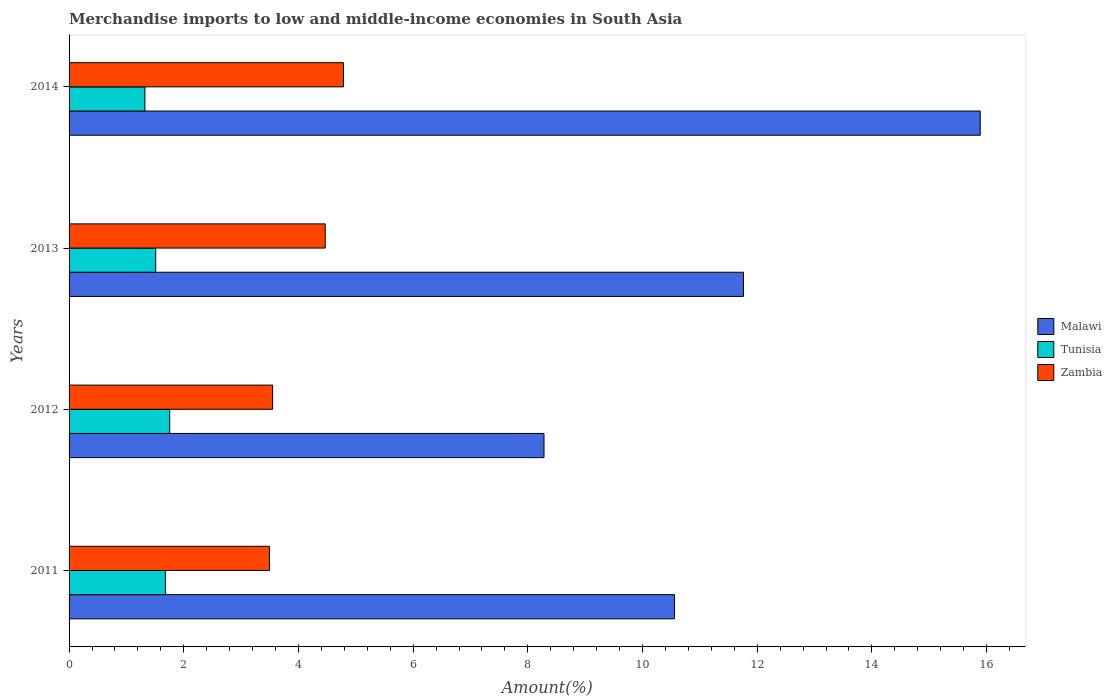Are the number of bars on each tick of the Y-axis equal?
Offer a terse response. Yes. How many bars are there on the 2nd tick from the top?
Provide a succinct answer. 3. What is the label of the 2nd group of bars from the top?
Your answer should be very brief. 2013. In how many cases, is the number of bars for a given year not equal to the number of legend labels?
Offer a very short reply. 0. What is the percentage of amount earned from merchandise imports in Tunisia in 2014?
Your answer should be very brief. 1.32. Across all years, what is the maximum percentage of amount earned from merchandise imports in Tunisia?
Give a very brief answer. 1.75. Across all years, what is the minimum percentage of amount earned from merchandise imports in Malawi?
Keep it short and to the point. 8.28. What is the total percentage of amount earned from merchandise imports in Zambia in the graph?
Your answer should be compact. 16.3. What is the difference between the percentage of amount earned from merchandise imports in Tunisia in 2011 and that in 2014?
Your response must be concise. 0.36. What is the difference between the percentage of amount earned from merchandise imports in Malawi in 2014 and the percentage of amount earned from merchandise imports in Zambia in 2012?
Your response must be concise. 12.34. What is the average percentage of amount earned from merchandise imports in Tunisia per year?
Offer a terse response. 1.57. In the year 2011, what is the difference between the percentage of amount earned from merchandise imports in Tunisia and percentage of amount earned from merchandise imports in Malawi?
Your answer should be compact. -8.88. What is the ratio of the percentage of amount earned from merchandise imports in Malawi in 2011 to that in 2012?
Give a very brief answer. 1.27. Is the percentage of amount earned from merchandise imports in Tunisia in 2012 less than that in 2014?
Offer a terse response. No. What is the difference between the highest and the second highest percentage of amount earned from merchandise imports in Tunisia?
Offer a very short reply. 0.07. What is the difference between the highest and the lowest percentage of amount earned from merchandise imports in Malawi?
Make the answer very short. 7.61. Is the sum of the percentage of amount earned from merchandise imports in Tunisia in 2011 and 2012 greater than the maximum percentage of amount earned from merchandise imports in Malawi across all years?
Give a very brief answer. No. What does the 3rd bar from the top in 2014 represents?
Your response must be concise. Malawi. What does the 3rd bar from the bottom in 2013 represents?
Offer a terse response. Zambia. Are all the bars in the graph horizontal?
Give a very brief answer. Yes. How many years are there in the graph?
Ensure brevity in your answer.  4. Are the values on the major ticks of X-axis written in scientific E-notation?
Your answer should be very brief. No. How many legend labels are there?
Your answer should be compact. 3. How are the legend labels stacked?
Your response must be concise. Vertical. What is the title of the graph?
Provide a short and direct response. Merchandise imports to low and middle-income economies in South Asia. Does "Korea (Republic)" appear as one of the legend labels in the graph?
Make the answer very short. No. What is the label or title of the X-axis?
Your answer should be very brief. Amount(%). What is the label or title of the Y-axis?
Your response must be concise. Years. What is the Amount(%) of Malawi in 2011?
Make the answer very short. 10.56. What is the Amount(%) of Tunisia in 2011?
Offer a very short reply. 1.68. What is the Amount(%) of Zambia in 2011?
Offer a very short reply. 3.49. What is the Amount(%) in Malawi in 2012?
Make the answer very short. 8.28. What is the Amount(%) in Tunisia in 2012?
Keep it short and to the point. 1.75. What is the Amount(%) in Zambia in 2012?
Give a very brief answer. 3.55. What is the Amount(%) of Malawi in 2013?
Ensure brevity in your answer.  11.76. What is the Amount(%) in Tunisia in 2013?
Offer a terse response. 1.51. What is the Amount(%) of Zambia in 2013?
Make the answer very short. 4.47. What is the Amount(%) of Malawi in 2014?
Provide a short and direct response. 15.89. What is the Amount(%) of Tunisia in 2014?
Your response must be concise. 1.32. What is the Amount(%) of Zambia in 2014?
Your answer should be very brief. 4.79. Across all years, what is the maximum Amount(%) of Malawi?
Make the answer very short. 15.89. Across all years, what is the maximum Amount(%) of Tunisia?
Ensure brevity in your answer.  1.75. Across all years, what is the maximum Amount(%) in Zambia?
Make the answer very short. 4.79. Across all years, what is the minimum Amount(%) in Malawi?
Ensure brevity in your answer.  8.28. Across all years, what is the minimum Amount(%) of Tunisia?
Provide a short and direct response. 1.32. Across all years, what is the minimum Amount(%) of Zambia?
Keep it short and to the point. 3.49. What is the total Amount(%) in Malawi in the graph?
Give a very brief answer. 46.49. What is the total Amount(%) of Tunisia in the graph?
Offer a terse response. 6.27. What is the total Amount(%) in Zambia in the graph?
Offer a very short reply. 16.3. What is the difference between the Amount(%) of Malawi in 2011 and that in 2012?
Your answer should be very brief. 2.28. What is the difference between the Amount(%) in Tunisia in 2011 and that in 2012?
Provide a short and direct response. -0.07. What is the difference between the Amount(%) in Zambia in 2011 and that in 2012?
Provide a succinct answer. -0.06. What is the difference between the Amount(%) in Malawi in 2011 and that in 2013?
Your response must be concise. -1.2. What is the difference between the Amount(%) of Tunisia in 2011 and that in 2013?
Your answer should be compact. 0.17. What is the difference between the Amount(%) of Zambia in 2011 and that in 2013?
Your response must be concise. -0.97. What is the difference between the Amount(%) of Malawi in 2011 and that in 2014?
Your answer should be compact. -5.33. What is the difference between the Amount(%) of Tunisia in 2011 and that in 2014?
Your answer should be compact. 0.36. What is the difference between the Amount(%) of Zambia in 2011 and that in 2014?
Offer a terse response. -1.29. What is the difference between the Amount(%) in Malawi in 2012 and that in 2013?
Make the answer very short. -3.48. What is the difference between the Amount(%) of Tunisia in 2012 and that in 2013?
Your answer should be compact. 0.24. What is the difference between the Amount(%) of Zambia in 2012 and that in 2013?
Your answer should be compact. -0.92. What is the difference between the Amount(%) in Malawi in 2012 and that in 2014?
Keep it short and to the point. -7.61. What is the difference between the Amount(%) in Tunisia in 2012 and that in 2014?
Make the answer very short. 0.43. What is the difference between the Amount(%) in Zambia in 2012 and that in 2014?
Offer a very short reply. -1.24. What is the difference between the Amount(%) in Malawi in 2013 and that in 2014?
Your answer should be very brief. -4.13. What is the difference between the Amount(%) of Tunisia in 2013 and that in 2014?
Give a very brief answer. 0.19. What is the difference between the Amount(%) of Zambia in 2013 and that in 2014?
Provide a short and direct response. -0.32. What is the difference between the Amount(%) in Malawi in 2011 and the Amount(%) in Tunisia in 2012?
Offer a very short reply. 8.8. What is the difference between the Amount(%) of Malawi in 2011 and the Amount(%) of Zambia in 2012?
Your response must be concise. 7.01. What is the difference between the Amount(%) in Tunisia in 2011 and the Amount(%) in Zambia in 2012?
Provide a succinct answer. -1.87. What is the difference between the Amount(%) in Malawi in 2011 and the Amount(%) in Tunisia in 2013?
Your answer should be compact. 9.05. What is the difference between the Amount(%) in Malawi in 2011 and the Amount(%) in Zambia in 2013?
Give a very brief answer. 6.09. What is the difference between the Amount(%) in Tunisia in 2011 and the Amount(%) in Zambia in 2013?
Provide a short and direct response. -2.79. What is the difference between the Amount(%) in Malawi in 2011 and the Amount(%) in Tunisia in 2014?
Offer a very short reply. 9.24. What is the difference between the Amount(%) in Malawi in 2011 and the Amount(%) in Zambia in 2014?
Your answer should be compact. 5.77. What is the difference between the Amount(%) of Tunisia in 2011 and the Amount(%) of Zambia in 2014?
Keep it short and to the point. -3.11. What is the difference between the Amount(%) of Malawi in 2012 and the Amount(%) of Tunisia in 2013?
Your answer should be compact. 6.77. What is the difference between the Amount(%) in Malawi in 2012 and the Amount(%) in Zambia in 2013?
Give a very brief answer. 3.82. What is the difference between the Amount(%) of Tunisia in 2012 and the Amount(%) of Zambia in 2013?
Your answer should be very brief. -2.71. What is the difference between the Amount(%) in Malawi in 2012 and the Amount(%) in Tunisia in 2014?
Provide a short and direct response. 6.96. What is the difference between the Amount(%) of Malawi in 2012 and the Amount(%) of Zambia in 2014?
Your response must be concise. 3.5. What is the difference between the Amount(%) in Tunisia in 2012 and the Amount(%) in Zambia in 2014?
Give a very brief answer. -3.03. What is the difference between the Amount(%) in Malawi in 2013 and the Amount(%) in Tunisia in 2014?
Offer a terse response. 10.44. What is the difference between the Amount(%) in Malawi in 2013 and the Amount(%) in Zambia in 2014?
Provide a short and direct response. 6.98. What is the difference between the Amount(%) in Tunisia in 2013 and the Amount(%) in Zambia in 2014?
Offer a very short reply. -3.27. What is the average Amount(%) of Malawi per year?
Give a very brief answer. 11.62. What is the average Amount(%) in Tunisia per year?
Keep it short and to the point. 1.57. What is the average Amount(%) in Zambia per year?
Your response must be concise. 4.07. In the year 2011, what is the difference between the Amount(%) of Malawi and Amount(%) of Tunisia?
Your response must be concise. 8.88. In the year 2011, what is the difference between the Amount(%) of Malawi and Amount(%) of Zambia?
Keep it short and to the point. 7.06. In the year 2011, what is the difference between the Amount(%) of Tunisia and Amount(%) of Zambia?
Offer a very short reply. -1.81. In the year 2012, what is the difference between the Amount(%) in Malawi and Amount(%) in Tunisia?
Keep it short and to the point. 6.53. In the year 2012, what is the difference between the Amount(%) of Malawi and Amount(%) of Zambia?
Make the answer very short. 4.73. In the year 2012, what is the difference between the Amount(%) in Tunisia and Amount(%) in Zambia?
Provide a succinct answer. -1.79. In the year 2013, what is the difference between the Amount(%) of Malawi and Amount(%) of Tunisia?
Offer a terse response. 10.25. In the year 2013, what is the difference between the Amount(%) of Malawi and Amount(%) of Zambia?
Offer a very short reply. 7.29. In the year 2013, what is the difference between the Amount(%) in Tunisia and Amount(%) in Zambia?
Your response must be concise. -2.96. In the year 2014, what is the difference between the Amount(%) in Malawi and Amount(%) in Tunisia?
Make the answer very short. 14.57. In the year 2014, what is the difference between the Amount(%) in Malawi and Amount(%) in Zambia?
Provide a short and direct response. 11.1. In the year 2014, what is the difference between the Amount(%) in Tunisia and Amount(%) in Zambia?
Keep it short and to the point. -3.46. What is the ratio of the Amount(%) in Malawi in 2011 to that in 2012?
Offer a very short reply. 1.27. What is the ratio of the Amount(%) of Tunisia in 2011 to that in 2012?
Offer a very short reply. 0.96. What is the ratio of the Amount(%) of Zambia in 2011 to that in 2012?
Make the answer very short. 0.98. What is the ratio of the Amount(%) in Malawi in 2011 to that in 2013?
Offer a very short reply. 0.9. What is the ratio of the Amount(%) of Tunisia in 2011 to that in 2013?
Offer a very short reply. 1.11. What is the ratio of the Amount(%) of Zambia in 2011 to that in 2013?
Provide a short and direct response. 0.78. What is the ratio of the Amount(%) in Malawi in 2011 to that in 2014?
Your response must be concise. 0.66. What is the ratio of the Amount(%) in Tunisia in 2011 to that in 2014?
Give a very brief answer. 1.27. What is the ratio of the Amount(%) in Zambia in 2011 to that in 2014?
Provide a short and direct response. 0.73. What is the ratio of the Amount(%) of Malawi in 2012 to that in 2013?
Make the answer very short. 0.7. What is the ratio of the Amount(%) of Tunisia in 2012 to that in 2013?
Offer a very short reply. 1.16. What is the ratio of the Amount(%) in Zambia in 2012 to that in 2013?
Your answer should be compact. 0.79. What is the ratio of the Amount(%) in Malawi in 2012 to that in 2014?
Keep it short and to the point. 0.52. What is the ratio of the Amount(%) in Tunisia in 2012 to that in 2014?
Your answer should be compact. 1.33. What is the ratio of the Amount(%) in Zambia in 2012 to that in 2014?
Your answer should be compact. 0.74. What is the ratio of the Amount(%) in Malawi in 2013 to that in 2014?
Provide a succinct answer. 0.74. What is the ratio of the Amount(%) in Tunisia in 2013 to that in 2014?
Make the answer very short. 1.14. What is the ratio of the Amount(%) of Zambia in 2013 to that in 2014?
Give a very brief answer. 0.93. What is the difference between the highest and the second highest Amount(%) in Malawi?
Your response must be concise. 4.13. What is the difference between the highest and the second highest Amount(%) of Tunisia?
Provide a succinct answer. 0.07. What is the difference between the highest and the second highest Amount(%) of Zambia?
Give a very brief answer. 0.32. What is the difference between the highest and the lowest Amount(%) in Malawi?
Your response must be concise. 7.61. What is the difference between the highest and the lowest Amount(%) in Tunisia?
Offer a very short reply. 0.43. What is the difference between the highest and the lowest Amount(%) of Zambia?
Keep it short and to the point. 1.29. 